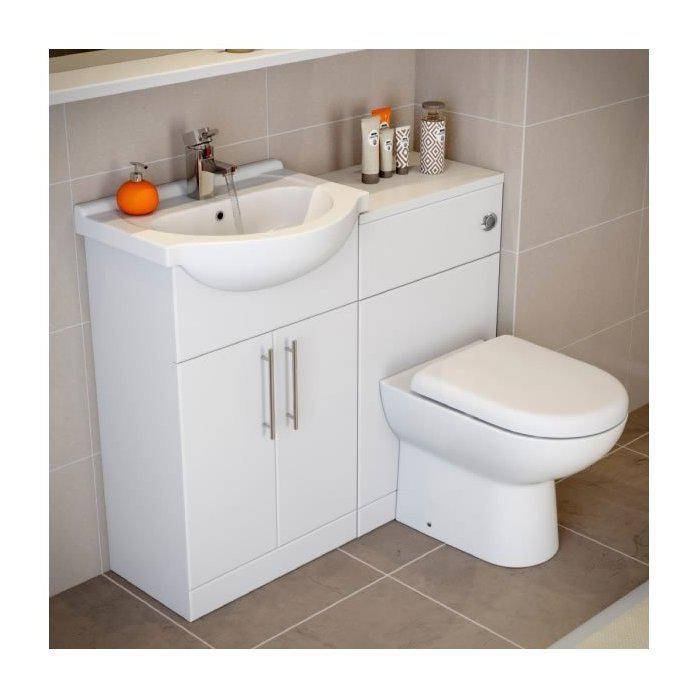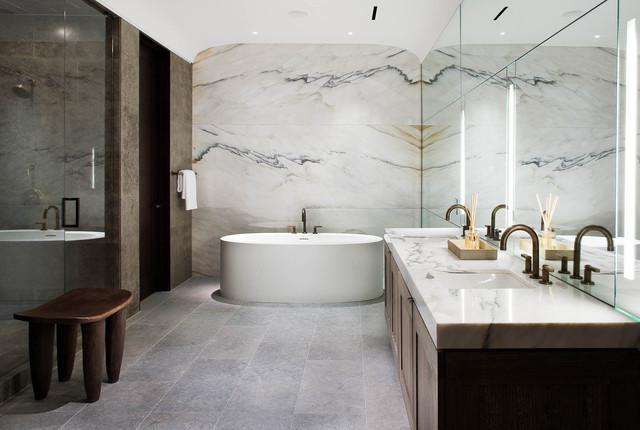The first image is the image on the left, the second image is the image on the right. For the images displayed, is the sentence "A white commode is attached at one end of a white vanity, with a white sink attached at the other end over double doors." factually correct? Answer yes or no. Yes. 